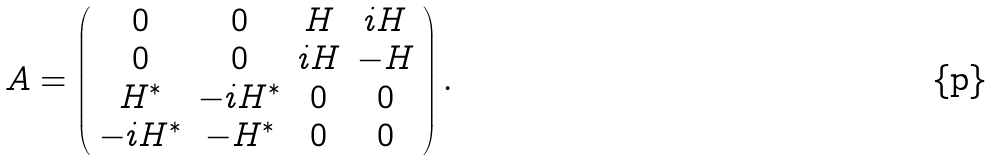Convert formula to latex. <formula><loc_0><loc_0><loc_500><loc_500>A = \left ( \begin{array} { c c c c } 0 & 0 & H & i H \\ 0 & 0 & i H & - H \\ H ^ { * } & - i H ^ { * } & 0 & 0 \\ - i H ^ { * } & - H ^ { * } & 0 & 0 \end{array} \right ) .</formula> 